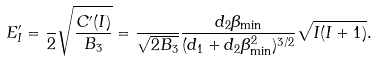<formula> <loc_0><loc_0><loc_500><loc_500>E ^ { \prime } _ { I } = \frac { } { 2 } \sqrt { \frac { C ^ { \prime } ( I ) } { B _ { 3 } } } = \frac { } { \sqrt { 2 B _ { 3 } } } \frac { d _ { 2 } \beta _ { \min } } { ( d _ { 1 } + d _ { 2 } \beta _ { \min } ^ { 2 } ) ^ { 3 / 2 } } \sqrt { I ( I + 1 ) } .</formula> 